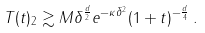<formula> <loc_0><loc_0><loc_500><loc_500>\| T ( t ) \| _ { 2 } \gtrsim M \delta ^ { \frac { d } { 2 } } e ^ { - \kappa \delta ^ { 2 } } ( 1 + t ) ^ { - \frac { d } { 4 } } \, .</formula> 